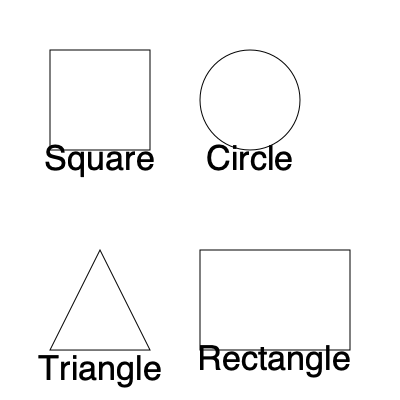As an eco-conscious influencer promoting zero-waste lifestyles, which of these container shapes would you recommend for maximum space efficiency when stacking multiple units in a storage area? To determine the most space-efficient shape for stacking containers, we need to consider how well each shape tessellates (fits together without gaps) in a three-dimensional space:

1. Square: Squares tessellate perfectly in both 2D and 3D space. When stacked, they leave no gaps between containers, maximizing space efficiency.

2. Circle: While circles can be efficient for individual container usage, they leave significant gaps when stacked or arranged together, resulting in wasted space.

3. Triangle: Equilateral triangles can tessellate in 2D, but they create gaps when stacked in 3D. They are not as efficient as squares for storage.

4. Rectangle: Like squares, rectangles tessellate perfectly in both 2D and 3D space, leaving no gaps when stacked.

To calculate the space efficiency, we can use the concept of packing density:

$$ \text{Packing Density} = \frac{\text{Volume of containers}}{\text{Total volume of space}} $$

For squares and rectangles, the packing density approaches 1 (or 100%) as the number of containers increases, meaning no space is wasted.

For circles, the maximum packing density in 2D is approximately 0.9069 (or 90.69%), known as the circle packing density, and it's even lower in 3D.

Triangular prisms would have a packing density lower than squares or rectangles due to gaps in 3D stacking.

Therefore, from a space efficiency perspective, square or rectangular containers would be the most recommended shapes for reusable packaging designs in a zero-waste lifestyle.
Answer: Square or rectangular containers 